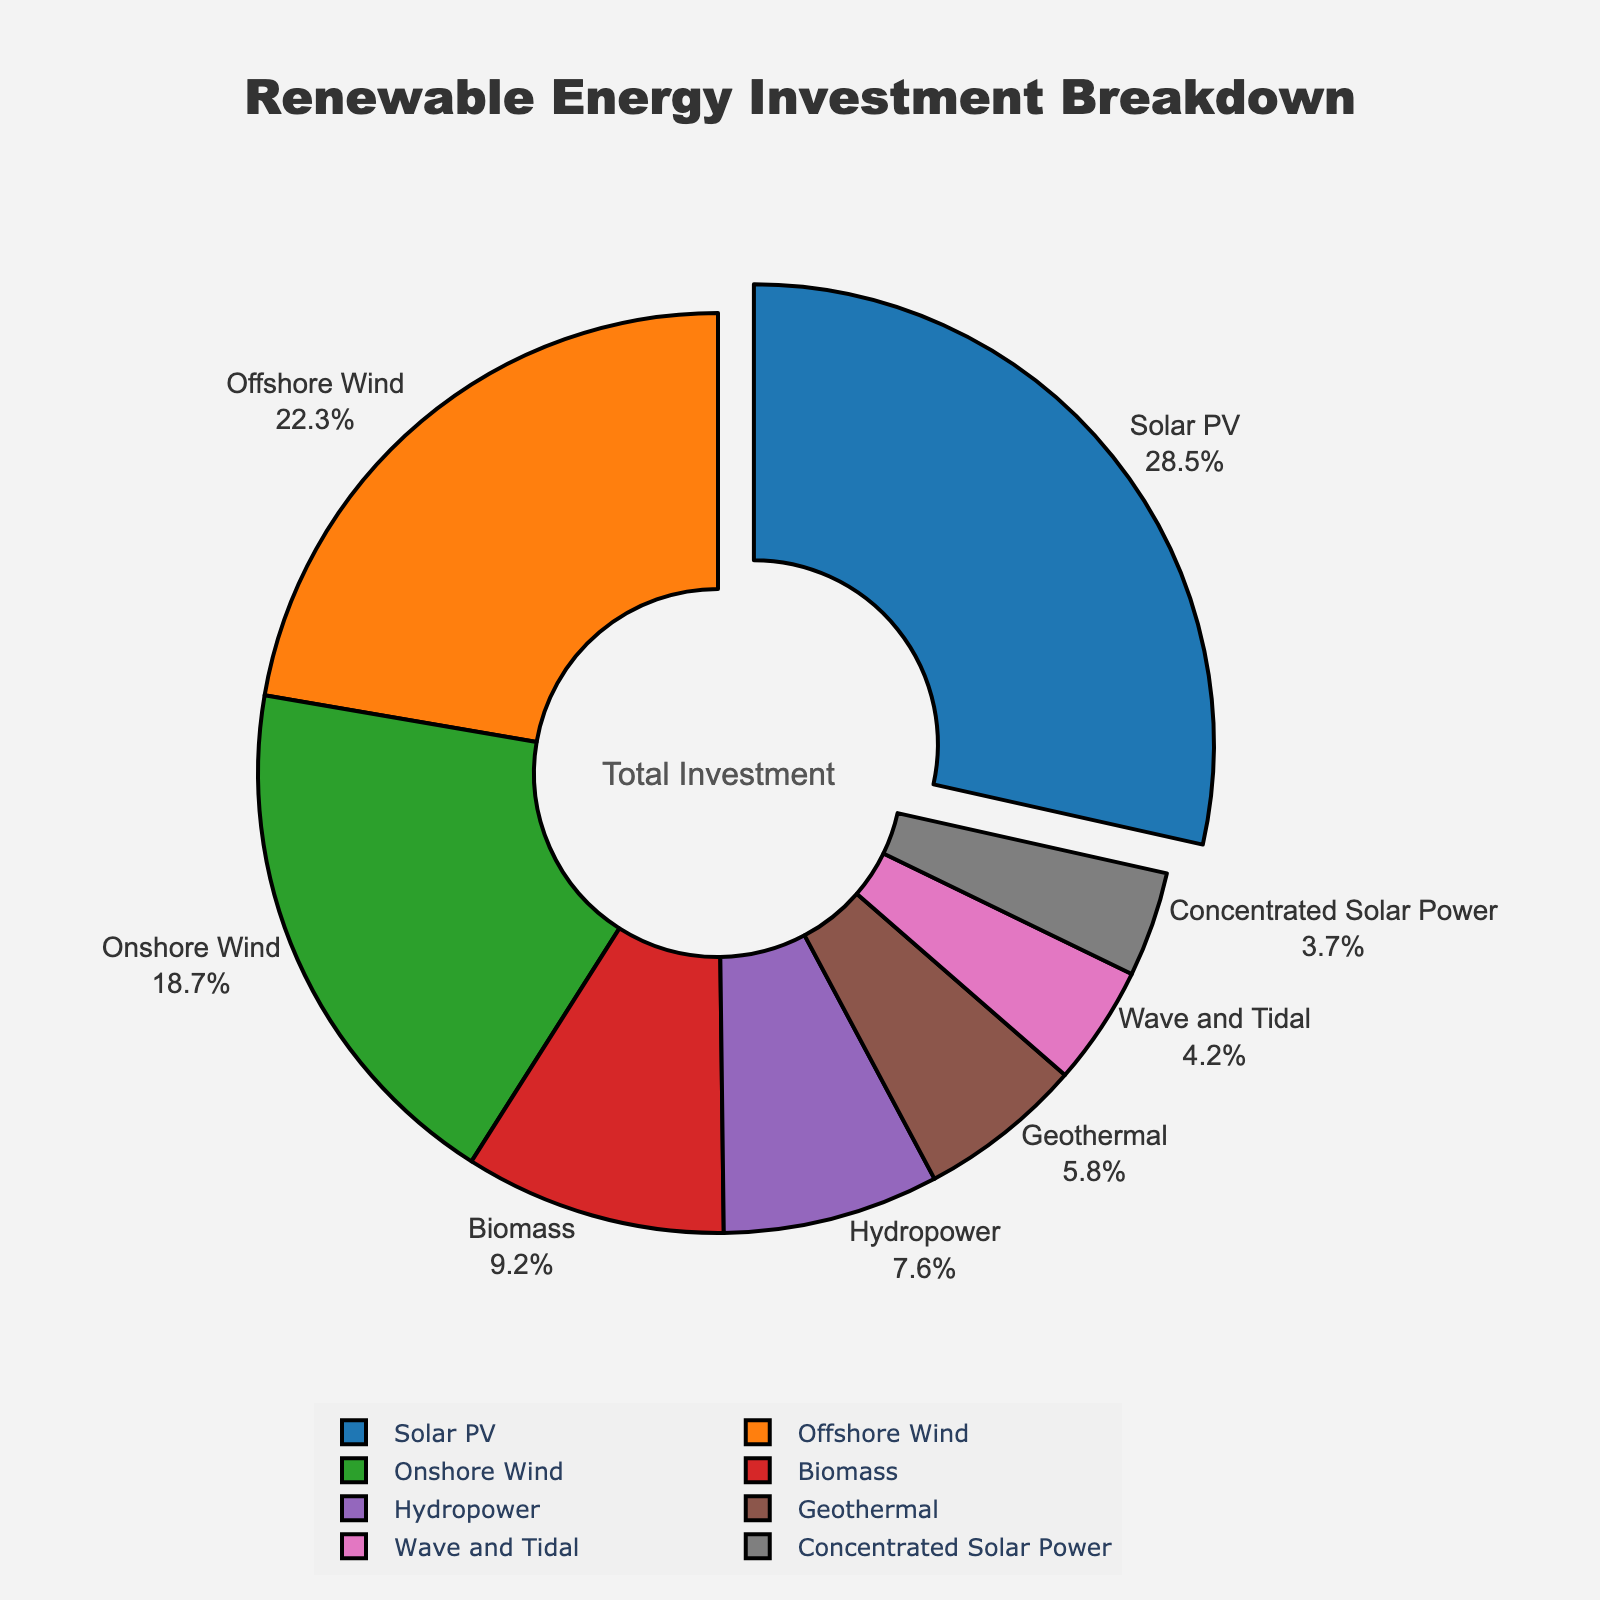Which technology receives the highest percentage of investment? The figure clearly shows that Solar PV has the largest segment in the pie chart, as indicated by its prominent size and the label showing 28.5%.
Answer: Solar PV What is the combined investment percentage for Wind technologies (Offshore Wind and Onshore Wind)? To find this, sum the investment percentages of Offshore Wind and Onshore Wind: 22.3% + 18.7% = 41%.
Answer: 41% How much more investment percentage does Solar PV have compared to Biomass? Subtract the investment percentage of Biomass from Solar PV: 28.5% - 9.2% = 19.3%.
Answer: 19.3% Which technology has the smallest investment percentage, and what is that percentage? The smallest segment in the pie chart belongs to Concentrated Solar Power, which is labeled with 3.7%.
Answer: Concentrated Solar Power, 3.7% How do the investment percentages of Geothermal and Hydropower compare? Comparing their values: Geothermal has 5.8%, and Hydropower has 7.6%. Thus, Hydropower has a higher investment percentage.
Answer: Hydropower has a higher percentage What is the total investment percentage for technologies contributing less than 10% each? Sum the percentages of Biomass, Hydropower, Geothermal, Wave and Tidal, and Concentrated Solar Power: 9.2% + 7.6% + 5.8% + 4.2% + 3.7% = 30.5%.
Answer: 30.5% Which technology occupies approximately one-fifth of the total investment? One-fifth of 100% is 20%, so look for the technology closest to this value. Offshore Wind is the closest with 22.3%.
Answer: Offshore Wind What is the difference in investment percentage between the top two technologies? Subtract the investment percentage of Offshore Wind (22.3%) from Solar PV (28.5%): 28.5% - 22.3% = 6.2%.
Answer: 6.2% If investments were redistributed such that each technology had equal shares, what would this new investment percentage be for each technology? There are 8 technologies, so each would get 100% / 8 = 12.5%.
Answer: 12.5% Which technology has a slightly larger investment percentage: Biomass or Geothermal? Comparing their values: Biomass has 9.2%, and Geothermal has 5.8%. Thus, Biomass has a slightly larger investment percentage.
Answer: Biomass 